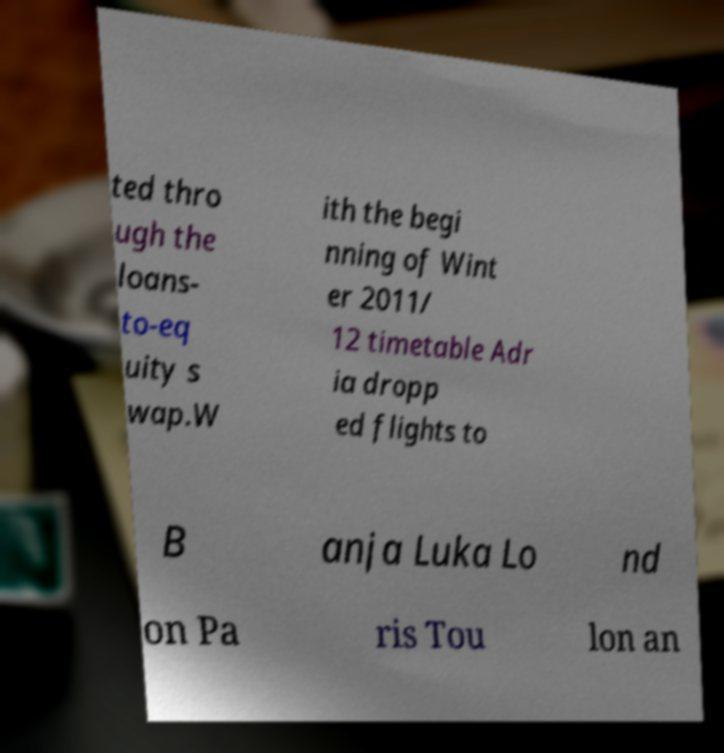Could you extract and type out the text from this image? ted thro ugh the loans- to-eq uity s wap.W ith the begi nning of Wint er 2011/ 12 timetable Adr ia dropp ed flights to B anja Luka Lo nd on Pa ris Tou lon an 